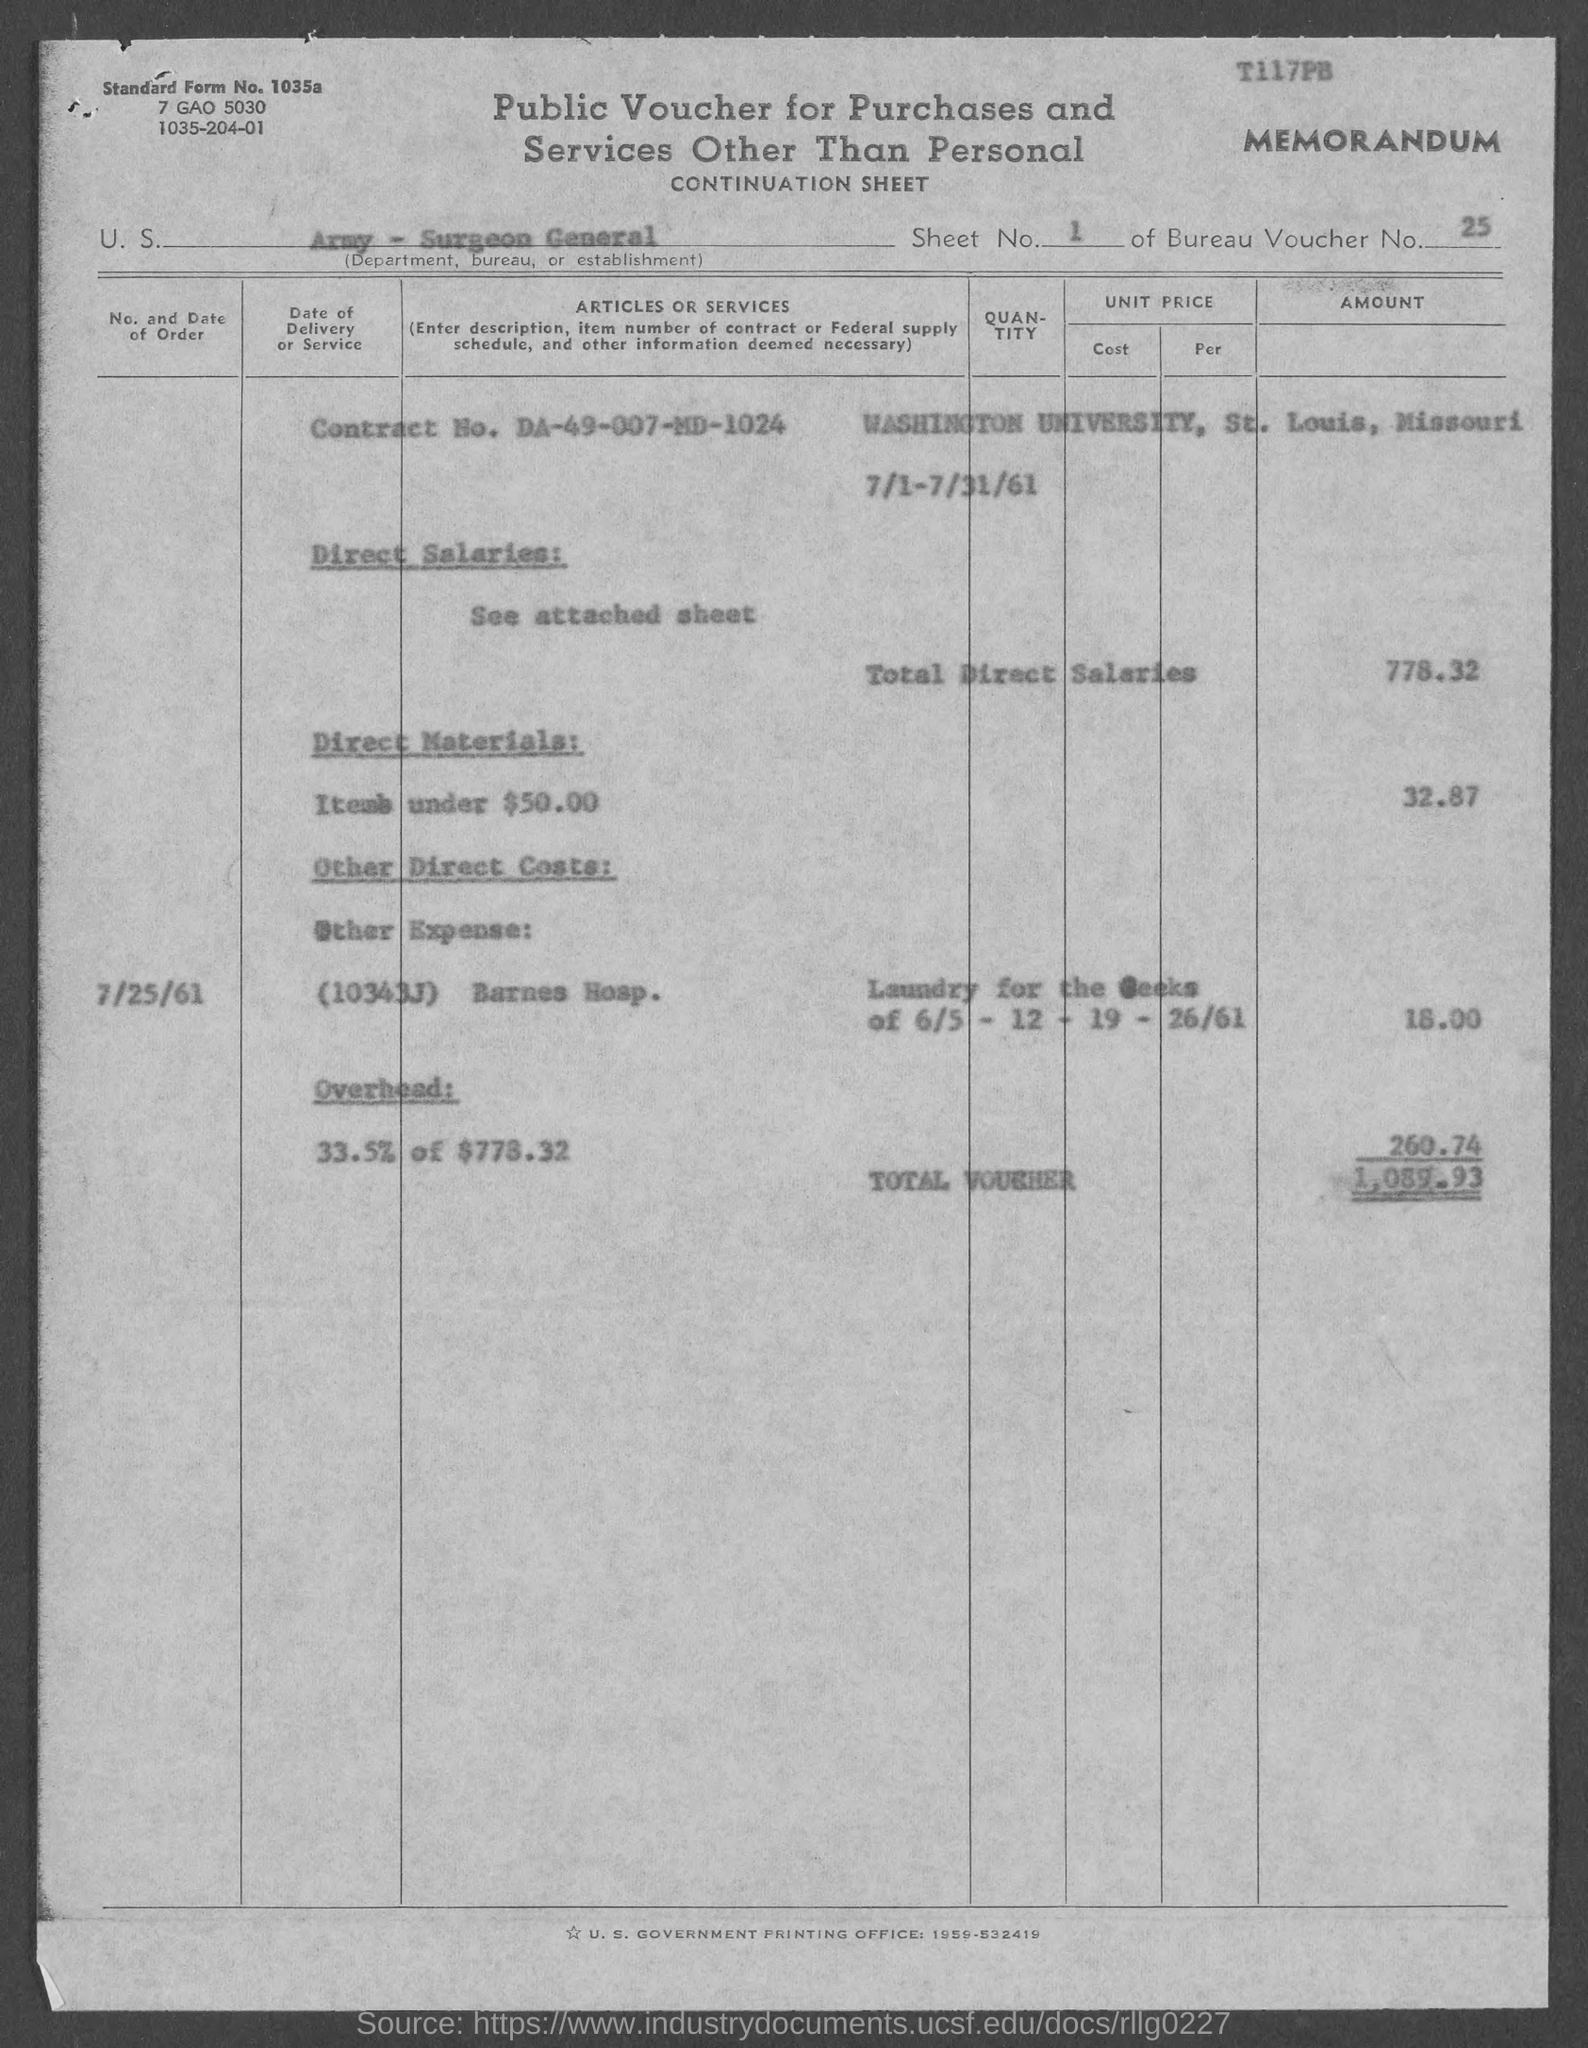What is the sheet no. mentioned in the given form ?
Ensure brevity in your answer.  1. What is the voucher number mentioned in the given form ?
Your answer should be very brief. 25. What is the contract no. mentioned in the given form ?
Your response must be concise. DA-49-007-MD-1024. What is the amount of total direct salaries mentioned in the given page ?
Offer a terse response. 778.32. What is the amount of direct materials mentioned in the given page ?
Offer a very short reply. 32.87. What is the amount of other direct cots mentioned in the given page ?
Give a very brief answer. 18. What is the amount of total voucher as mentioned in the given form ?
Your answer should be compact. 1,089.93. What is the date of order mentioned in the given page ?
Ensure brevity in your answer.  7/25/61. 